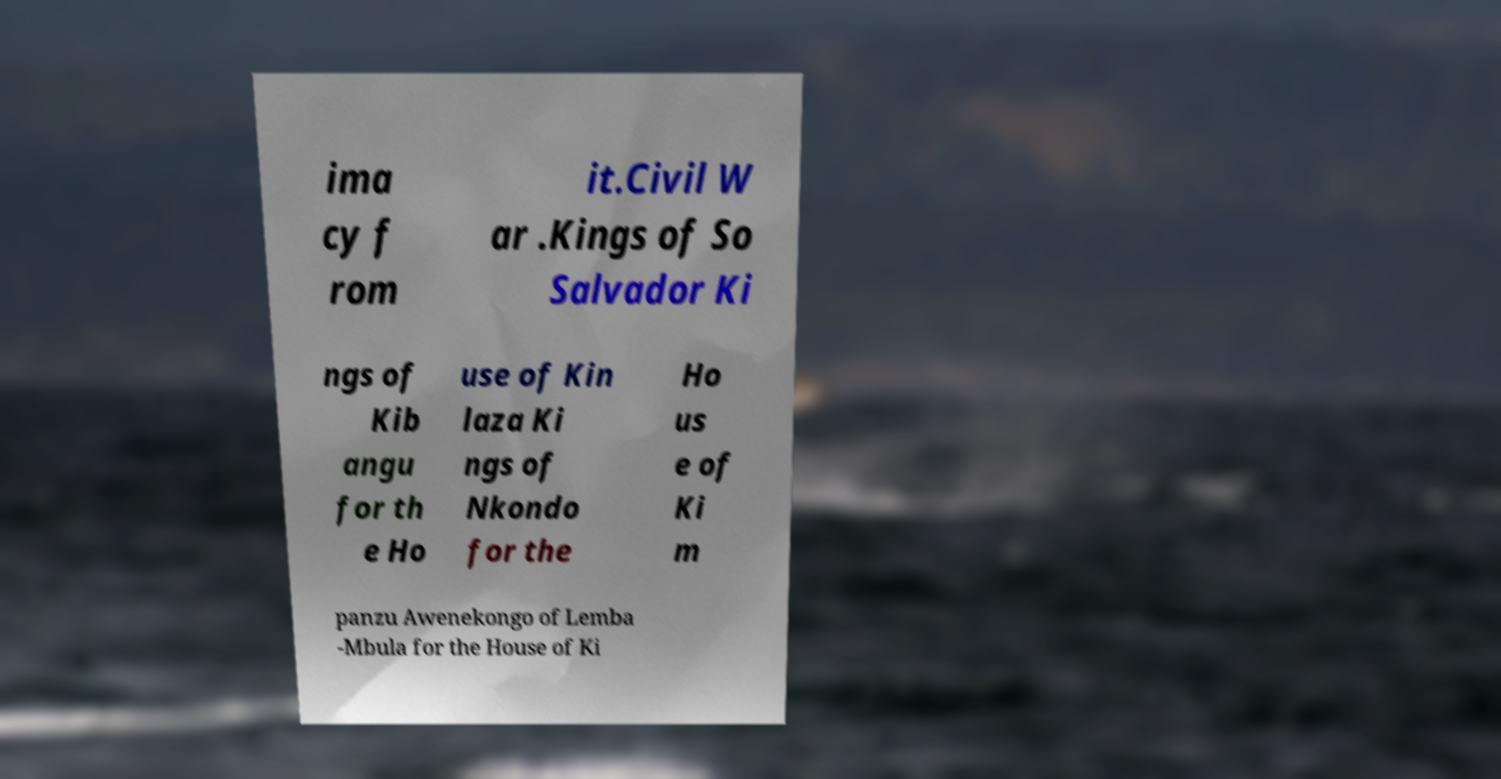I need the written content from this picture converted into text. Can you do that? ima cy f rom it.Civil W ar .Kings of So Salvador Ki ngs of Kib angu for th e Ho use of Kin laza Ki ngs of Nkondo for the Ho us e of Ki m panzu Awenekongo of Lemba -Mbula for the House of Ki 